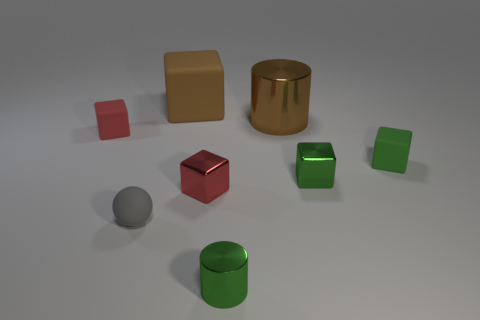Subtract all red cubes. How many cubes are left? 3 Subtract all green shiny blocks. How many blocks are left? 4 Subtract 1 blocks. How many blocks are left? 4 Add 1 green metallic cylinders. How many objects exist? 9 Subtract all yellow cubes. Subtract all yellow cylinders. How many cubes are left? 5 Subtract all spheres. How many objects are left? 7 Add 8 big brown rubber things. How many big brown rubber things exist? 9 Subtract 0 cyan cubes. How many objects are left? 8 Subtract all big green matte cylinders. Subtract all small gray balls. How many objects are left? 7 Add 5 brown things. How many brown things are left? 7 